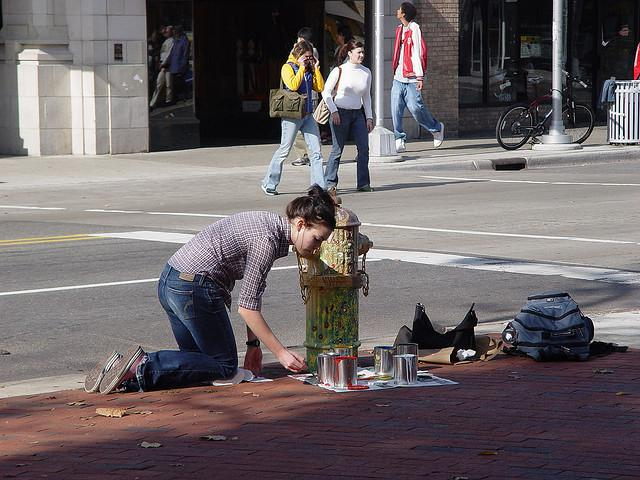What kind of brush is being used? Please explain your reasoning. paint. A paintbrush is ebing used near the paint cans. 